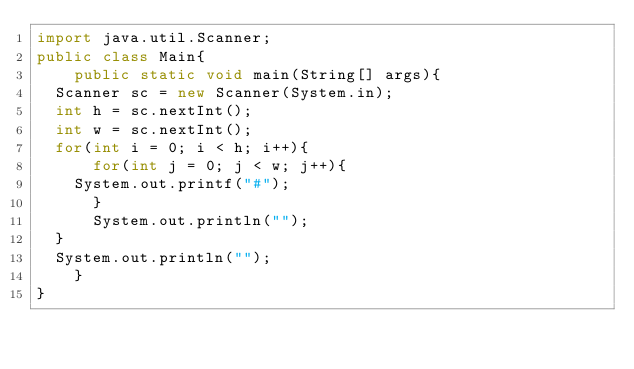Convert code to text. <code><loc_0><loc_0><loc_500><loc_500><_Java_>import java.util.Scanner;
public class Main{
    public static void main(String[] args){
	Scanner sc = new Scanner(System.in);
	int h = sc.nextInt();
	int w = sc.nextInt();
	for(int i = 0; i < h; i++){
	    for(int j = 0; j < w; j++){
		System.out.printf("#");
	    }
	    System.out.println("");
	}
	System.out.println("");
    }
}</code> 